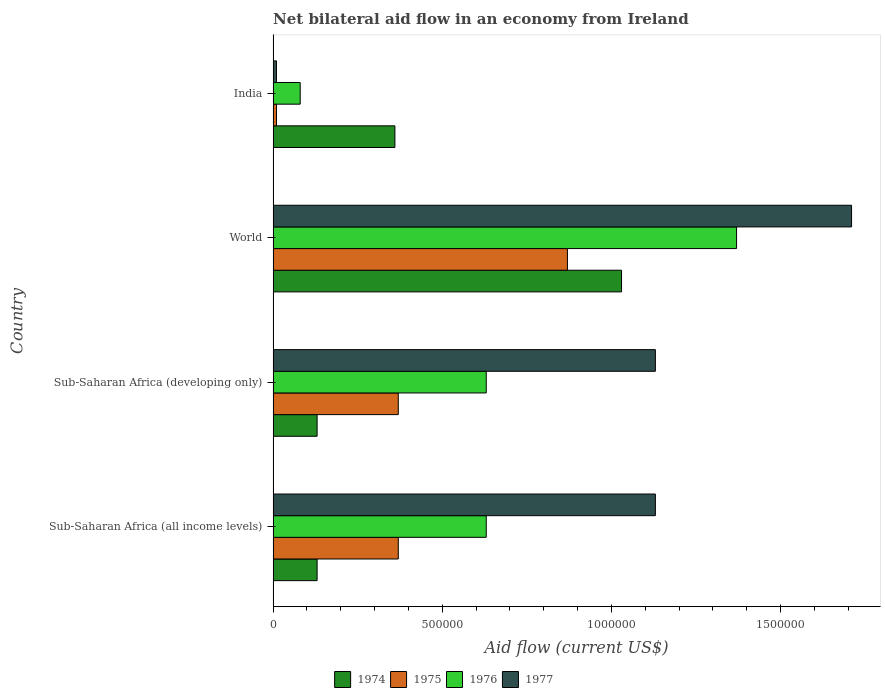How many groups of bars are there?
Give a very brief answer. 4. Are the number of bars per tick equal to the number of legend labels?
Give a very brief answer. Yes. Are the number of bars on each tick of the Y-axis equal?
Your response must be concise. Yes. How many bars are there on the 1st tick from the top?
Your answer should be compact. 4. How many bars are there on the 4th tick from the bottom?
Your response must be concise. 4. Across all countries, what is the maximum net bilateral aid flow in 1974?
Offer a terse response. 1.03e+06. In which country was the net bilateral aid flow in 1974 minimum?
Offer a terse response. Sub-Saharan Africa (all income levels). What is the total net bilateral aid flow in 1975 in the graph?
Your response must be concise. 1.62e+06. What is the difference between the net bilateral aid flow in 1977 in India and that in Sub-Saharan Africa (developing only)?
Ensure brevity in your answer.  -1.12e+06. What is the difference between the net bilateral aid flow in 1976 in India and the net bilateral aid flow in 1977 in Sub-Saharan Africa (developing only)?
Keep it short and to the point. -1.05e+06. What is the average net bilateral aid flow in 1976 per country?
Keep it short and to the point. 6.78e+05. What is the difference between the net bilateral aid flow in 1977 and net bilateral aid flow in 1974 in India?
Provide a succinct answer. -3.50e+05. What is the ratio of the net bilateral aid flow in 1974 in Sub-Saharan Africa (all income levels) to that in Sub-Saharan Africa (developing only)?
Keep it short and to the point. 1. Is the net bilateral aid flow in 1974 in Sub-Saharan Africa (developing only) less than that in World?
Offer a very short reply. Yes. What is the difference between the highest and the second highest net bilateral aid flow in 1976?
Your answer should be compact. 7.40e+05. What is the difference between the highest and the lowest net bilateral aid flow in 1975?
Your answer should be compact. 8.60e+05. In how many countries, is the net bilateral aid flow in 1977 greater than the average net bilateral aid flow in 1977 taken over all countries?
Provide a succinct answer. 3. Is the sum of the net bilateral aid flow in 1976 in Sub-Saharan Africa (developing only) and World greater than the maximum net bilateral aid flow in 1974 across all countries?
Provide a succinct answer. Yes. Is it the case that in every country, the sum of the net bilateral aid flow in 1977 and net bilateral aid flow in 1976 is greater than the sum of net bilateral aid flow in 1975 and net bilateral aid flow in 1974?
Make the answer very short. No. What does the 4th bar from the top in India represents?
Offer a very short reply. 1974. What does the 1st bar from the bottom in India represents?
Offer a terse response. 1974. Is it the case that in every country, the sum of the net bilateral aid flow in 1976 and net bilateral aid flow in 1975 is greater than the net bilateral aid flow in 1977?
Make the answer very short. No. Are all the bars in the graph horizontal?
Your answer should be compact. Yes. Are the values on the major ticks of X-axis written in scientific E-notation?
Offer a terse response. No. Does the graph contain any zero values?
Offer a very short reply. No. Does the graph contain grids?
Ensure brevity in your answer.  No. How are the legend labels stacked?
Offer a terse response. Horizontal. What is the title of the graph?
Your answer should be compact. Net bilateral aid flow in an economy from Ireland. What is the label or title of the X-axis?
Provide a succinct answer. Aid flow (current US$). What is the label or title of the Y-axis?
Give a very brief answer. Country. What is the Aid flow (current US$) of 1975 in Sub-Saharan Africa (all income levels)?
Your answer should be compact. 3.70e+05. What is the Aid flow (current US$) in 1976 in Sub-Saharan Africa (all income levels)?
Offer a very short reply. 6.30e+05. What is the Aid flow (current US$) in 1977 in Sub-Saharan Africa (all income levels)?
Provide a short and direct response. 1.13e+06. What is the Aid flow (current US$) in 1976 in Sub-Saharan Africa (developing only)?
Offer a very short reply. 6.30e+05. What is the Aid flow (current US$) of 1977 in Sub-Saharan Africa (developing only)?
Ensure brevity in your answer.  1.13e+06. What is the Aid flow (current US$) of 1974 in World?
Give a very brief answer. 1.03e+06. What is the Aid flow (current US$) of 1975 in World?
Your response must be concise. 8.70e+05. What is the Aid flow (current US$) in 1976 in World?
Your answer should be compact. 1.37e+06. What is the Aid flow (current US$) of 1977 in World?
Offer a terse response. 1.71e+06. What is the Aid flow (current US$) in 1977 in India?
Offer a terse response. 10000. Across all countries, what is the maximum Aid flow (current US$) in 1974?
Offer a terse response. 1.03e+06. Across all countries, what is the maximum Aid flow (current US$) in 1975?
Your response must be concise. 8.70e+05. Across all countries, what is the maximum Aid flow (current US$) in 1976?
Your answer should be compact. 1.37e+06. Across all countries, what is the maximum Aid flow (current US$) of 1977?
Offer a terse response. 1.71e+06. Across all countries, what is the minimum Aid flow (current US$) in 1976?
Give a very brief answer. 8.00e+04. Across all countries, what is the minimum Aid flow (current US$) in 1977?
Make the answer very short. 10000. What is the total Aid flow (current US$) in 1974 in the graph?
Provide a short and direct response. 1.65e+06. What is the total Aid flow (current US$) in 1975 in the graph?
Provide a short and direct response. 1.62e+06. What is the total Aid flow (current US$) in 1976 in the graph?
Your answer should be compact. 2.71e+06. What is the total Aid flow (current US$) in 1977 in the graph?
Give a very brief answer. 3.98e+06. What is the difference between the Aid flow (current US$) of 1974 in Sub-Saharan Africa (all income levels) and that in Sub-Saharan Africa (developing only)?
Your answer should be compact. 0. What is the difference between the Aid flow (current US$) of 1975 in Sub-Saharan Africa (all income levels) and that in Sub-Saharan Africa (developing only)?
Offer a very short reply. 0. What is the difference between the Aid flow (current US$) of 1976 in Sub-Saharan Africa (all income levels) and that in Sub-Saharan Africa (developing only)?
Make the answer very short. 0. What is the difference between the Aid flow (current US$) of 1974 in Sub-Saharan Africa (all income levels) and that in World?
Your response must be concise. -9.00e+05. What is the difference between the Aid flow (current US$) in 1975 in Sub-Saharan Africa (all income levels) and that in World?
Your response must be concise. -5.00e+05. What is the difference between the Aid flow (current US$) of 1976 in Sub-Saharan Africa (all income levels) and that in World?
Give a very brief answer. -7.40e+05. What is the difference between the Aid flow (current US$) in 1977 in Sub-Saharan Africa (all income levels) and that in World?
Ensure brevity in your answer.  -5.80e+05. What is the difference between the Aid flow (current US$) in 1975 in Sub-Saharan Africa (all income levels) and that in India?
Give a very brief answer. 3.60e+05. What is the difference between the Aid flow (current US$) in 1976 in Sub-Saharan Africa (all income levels) and that in India?
Make the answer very short. 5.50e+05. What is the difference between the Aid flow (current US$) in 1977 in Sub-Saharan Africa (all income levels) and that in India?
Your answer should be very brief. 1.12e+06. What is the difference between the Aid flow (current US$) in 1974 in Sub-Saharan Africa (developing only) and that in World?
Provide a succinct answer. -9.00e+05. What is the difference between the Aid flow (current US$) of 1975 in Sub-Saharan Africa (developing only) and that in World?
Offer a very short reply. -5.00e+05. What is the difference between the Aid flow (current US$) in 1976 in Sub-Saharan Africa (developing only) and that in World?
Make the answer very short. -7.40e+05. What is the difference between the Aid flow (current US$) in 1977 in Sub-Saharan Africa (developing only) and that in World?
Your response must be concise. -5.80e+05. What is the difference between the Aid flow (current US$) of 1976 in Sub-Saharan Africa (developing only) and that in India?
Offer a terse response. 5.50e+05. What is the difference between the Aid flow (current US$) of 1977 in Sub-Saharan Africa (developing only) and that in India?
Offer a terse response. 1.12e+06. What is the difference between the Aid flow (current US$) in 1974 in World and that in India?
Ensure brevity in your answer.  6.70e+05. What is the difference between the Aid flow (current US$) of 1975 in World and that in India?
Your response must be concise. 8.60e+05. What is the difference between the Aid flow (current US$) of 1976 in World and that in India?
Give a very brief answer. 1.29e+06. What is the difference between the Aid flow (current US$) of 1977 in World and that in India?
Offer a very short reply. 1.70e+06. What is the difference between the Aid flow (current US$) in 1974 in Sub-Saharan Africa (all income levels) and the Aid flow (current US$) in 1975 in Sub-Saharan Africa (developing only)?
Give a very brief answer. -2.40e+05. What is the difference between the Aid flow (current US$) of 1974 in Sub-Saharan Africa (all income levels) and the Aid flow (current US$) of 1976 in Sub-Saharan Africa (developing only)?
Provide a short and direct response. -5.00e+05. What is the difference between the Aid flow (current US$) of 1975 in Sub-Saharan Africa (all income levels) and the Aid flow (current US$) of 1976 in Sub-Saharan Africa (developing only)?
Your answer should be compact. -2.60e+05. What is the difference between the Aid flow (current US$) in 1975 in Sub-Saharan Africa (all income levels) and the Aid flow (current US$) in 1977 in Sub-Saharan Africa (developing only)?
Offer a very short reply. -7.60e+05. What is the difference between the Aid flow (current US$) of 1976 in Sub-Saharan Africa (all income levels) and the Aid flow (current US$) of 1977 in Sub-Saharan Africa (developing only)?
Your answer should be compact. -5.00e+05. What is the difference between the Aid flow (current US$) in 1974 in Sub-Saharan Africa (all income levels) and the Aid flow (current US$) in 1975 in World?
Your answer should be very brief. -7.40e+05. What is the difference between the Aid flow (current US$) of 1974 in Sub-Saharan Africa (all income levels) and the Aid flow (current US$) of 1976 in World?
Ensure brevity in your answer.  -1.24e+06. What is the difference between the Aid flow (current US$) in 1974 in Sub-Saharan Africa (all income levels) and the Aid flow (current US$) in 1977 in World?
Your answer should be very brief. -1.58e+06. What is the difference between the Aid flow (current US$) of 1975 in Sub-Saharan Africa (all income levels) and the Aid flow (current US$) of 1977 in World?
Offer a very short reply. -1.34e+06. What is the difference between the Aid flow (current US$) of 1976 in Sub-Saharan Africa (all income levels) and the Aid flow (current US$) of 1977 in World?
Keep it short and to the point. -1.08e+06. What is the difference between the Aid flow (current US$) of 1974 in Sub-Saharan Africa (all income levels) and the Aid flow (current US$) of 1976 in India?
Your answer should be compact. 5.00e+04. What is the difference between the Aid flow (current US$) in 1974 in Sub-Saharan Africa (all income levels) and the Aid flow (current US$) in 1977 in India?
Offer a terse response. 1.20e+05. What is the difference between the Aid flow (current US$) in 1975 in Sub-Saharan Africa (all income levels) and the Aid flow (current US$) in 1976 in India?
Your response must be concise. 2.90e+05. What is the difference between the Aid flow (current US$) of 1976 in Sub-Saharan Africa (all income levels) and the Aid flow (current US$) of 1977 in India?
Make the answer very short. 6.20e+05. What is the difference between the Aid flow (current US$) of 1974 in Sub-Saharan Africa (developing only) and the Aid flow (current US$) of 1975 in World?
Provide a succinct answer. -7.40e+05. What is the difference between the Aid flow (current US$) of 1974 in Sub-Saharan Africa (developing only) and the Aid flow (current US$) of 1976 in World?
Your answer should be very brief. -1.24e+06. What is the difference between the Aid flow (current US$) in 1974 in Sub-Saharan Africa (developing only) and the Aid flow (current US$) in 1977 in World?
Keep it short and to the point. -1.58e+06. What is the difference between the Aid flow (current US$) in 1975 in Sub-Saharan Africa (developing only) and the Aid flow (current US$) in 1977 in World?
Provide a short and direct response. -1.34e+06. What is the difference between the Aid flow (current US$) in 1976 in Sub-Saharan Africa (developing only) and the Aid flow (current US$) in 1977 in World?
Provide a short and direct response. -1.08e+06. What is the difference between the Aid flow (current US$) in 1974 in Sub-Saharan Africa (developing only) and the Aid flow (current US$) in 1975 in India?
Offer a very short reply. 1.20e+05. What is the difference between the Aid flow (current US$) in 1974 in Sub-Saharan Africa (developing only) and the Aid flow (current US$) in 1976 in India?
Give a very brief answer. 5.00e+04. What is the difference between the Aid flow (current US$) of 1974 in Sub-Saharan Africa (developing only) and the Aid flow (current US$) of 1977 in India?
Ensure brevity in your answer.  1.20e+05. What is the difference between the Aid flow (current US$) of 1975 in Sub-Saharan Africa (developing only) and the Aid flow (current US$) of 1976 in India?
Your response must be concise. 2.90e+05. What is the difference between the Aid flow (current US$) of 1976 in Sub-Saharan Africa (developing only) and the Aid flow (current US$) of 1977 in India?
Ensure brevity in your answer.  6.20e+05. What is the difference between the Aid flow (current US$) in 1974 in World and the Aid flow (current US$) in 1975 in India?
Provide a short and direct response. 1.02e+06. What is the difference between the Aid flow (current US$) in 1974 in World and the Aid flow (current US$) in 1976 in India?
Offer a terse response. 9.50e+05. What is the difference between the Aid flow (current US$) of 1974 in World and the Aid flow (current US$) of 1977 in India?
Keep it short and to the point. 1.02e+06. What is the difference between the Aid flow (current US$) of 1975 in World and the Aid flow (current US$) of 1976 in India?
Your response must be concise. 7.90e+05. What is the difference between the Aid flow (current US$) of 1975 in World and the Aid flow (current US$) of 1977 in India?
Make the answer very short. 8.60e+05. What is the difference between the Aid flow (current US$) in 1976 in World and the Aid flow (current US$) in 1977 in India?
Give a very brief answer. 1.36e+06. What is the average Aid flow (current US$) of 1974 per country?
Your answer should be compact. 4.12e+05. What is the average Aid flow (current US$) of 1975 per country?
Your answer should be compact. 4.05e+05. What is the average Aid flow (current US$) of 1976 per country?
Provide a short and direct response. 6.78e+05. What is the average Aid flow (current US$) of 1977 per country?
Ensure brevity in your answer.  9.95e+05. What is the difference between the Aid flow (current US$) of 1974 and Aid flow (current US$) of 1975 in Sub-Saharan Africa (all income levels)?
Provide a succinct answer. -2.40e+05. What is the difference between the Aid flow (current US$) of 1974 and Aid flow (current US$) of 1976 in Sub-Saharan Africa (all income levels)?
Offer a terse response. -5.00e+05. What is the difference between the Aid flow (current US$) in 1974 and Aid flow (current US$) in 1977 in Sub-Saharan Africa (all income levels)?
Offer a terse response. -1.00e+06. What is the difference between the Aid flow (current US$) of 1975 and Aid flow (current US$) of 1976 in Sub-Saharan Africa (all income levels)?
Your response must be concise. -2.60e+05. What is the difference between the Aid flow (current US$) in 1975 and Aid flow (current US$) in 1977 in Sub-Saharan Africa (all income levels)?
Give a very brief answer. -7.60e+05. What is the difference between the Aid flow (current US$) of 1976 and Aid flow (current US$) of 1977 in Sub-Saharan Africa (all income levels)?
Your answer should be very brief. -5.00e+05. What is the difference between the Aid flow (current US$) of 1974 and Aid flow (current US$) of 1976 in Sub-Saharan Africa (developing only)?
Provide a succinct answer. -5.00e+05. What is the difference between the Aid flow (current US$) in 1974 and Aid flow (current US$) in 1977 in Sub-Saharan Africa (developing only)?
Offer a terse response. -1.00e+06. What is the difference between the Aid flow (current US$) of 1975 and Aid flow (current US$) of 1976 in Sub-Saharan Africa (developing only)?
Your response must be concise. -2.60e+05. What is the difference between the Aid flow (current US$) of 1975 and Aid flow (current US$) of 1977 in Sub-Saharan Africa (developing only)?
Your answer should be very brief. -7.60e+05. What is the difference between the Aid flow (current US$) of 1976 and Aid flow (current US$) of 1977 in Sub-Saharan Africa (developing only)?
Give a very brief answer. -5.00e+05. What is the difference between the Aid flow (current US$) in 1974 and Aid flow (current US$) in 1976 in World?
Provide a succinct answer. -3.40e+05. What is the difference between the Aid flow (current US$) in 1974 and Aid flow (current US$) in 1977 in World?
Give a very brief answer. -6.80e+05. What is the difference between the Aid flow (current US$) in 1975 and Aid flow (current US$) in 1976 in World?
Your response must be concise. -5.00e+05. What is the difference between the Aid flow (current US$) of 1975 and Aid flow (current US$) of 1977 in World?
Provide a short and direct response. -8.40e+05. What is the difference between the Aid flow (current US$) in 1974 and Aid flow (current US$) in 1975 in India?
Your response must be concise. 3.50e+05. What is the difference between the Aid flow (current US$) of 1974 and Aid flow (current US$) of 1976 in India?
Offer a terse response. 2.80e+05. What is the difference between the Aid flow (current US$) in 1974 and Aid flow (current US$) in 1977 in India?
Your answer should be very brief. 3.50e+05. What is the difference between the Aid flow (current US$) in 1975 and Aid flow (current US$) in 1976 in India?
Make the answer very short. -7.00e+04. What is the difference between the Aid flow (current US$) in 1976 and Aid flow (current US$) in 1977 in India?
Your response must be concise. 7.00e+04. What is the ratio of the Aid flow (current US$) of 1974 in Sub-Saharan Africa (all income levels) to that in Sub-Saharan Africa (developing only)?
Your answer should be very brief. 1. What is the ratio of the Aid flow (current US$) of 1975 in Sub-Saharan Africa (all income levels) to that in Sub-Saharan Africa (developing only)?
Offer a terse response. 1. What is the ratio of the Aid flow (current US$) in 1974 in Sub-Saharan Africa (all income levels) to that in World?
Your response must be concise. 0.13. What is the ratio of the Aid flow (current US$) in 1975 in Sub-Saharan Africa (all income levels) to that in World?
Make the answer very short. 0.43. What is the ratio of the Aid flow (current US$) in 1976 in Sub-Saharan Africa (all income levels) to that in World?
Give a very brief answer. 0.46. What is the ratio of the Aid flow (current US$) of 1977 in Sub-Saharan Africa (all income levels) to that in World?
Keep it short and to the point. 0.66. What is the ratio of the Aid flow (current US$) of 1974 in Sub-Saharan Africa (all income levels) to that in India?
Provide a succinct answer. 0.36. What is the ratio of the Aid flow (current US$) in 1976 in Sub-Saharan Africa (all income levels) to that in India?
Provide a succinct answer. 7.88. What is the ratio of the Aid flow (current US$) of 1977 in Sub-Saharan Africa (all income levels) to that in India?
Keep it short and to the point. 113. What is the ratio of the Aid flow (current US$) in 1974 in Sub-Saharan Africa (developing only) to that in World?
Make the answer very short. 0.13. What is the ratio of the Aid flow (current US$) in 1975 in Sub-Saharan Africa (developing only) to that in World?
Give a very brief answer. 0.43. What is the ratio of the Aid flow (current US$) in 1976 in Sub-Saharan Africa (developing only) to that in World?
Your response must be concise. 0.46. What is the ratio of the Aid flow (current US$) in 1977 in Sub-Saharan Africa (developing only) to that in World?
Ensure brevity in your answer.  0.66. What is the ratio of the Aid flow (current US$) in 1974 in Sub-Saharan Africa (developing only) to that in India?
Keep it short and to the point. 0.36. What is the ratio of the Aid flow (current US$) in 1976 in Sub-Saharan Africa (developing only) to that in India?
Your response must be concise. 7.88. What is the ratio of the Aid flow (current US$) of 1977 in Sub-Saharan Africa (developing only) to that in India?
Your answer should be very brief. 113. What is the ratio of the Aid flow (current US$) in 1974 in World to that in India?
Provide a short and direct response. 2.86. What is the ratio of the Aid flow (current US$) of 1975 in World to that in India?
Provide a short and direct response. 87. What is the ratio of the Aid flow (current US$) in 1976 in World to that in India?
Your response must be concise. 17.12. What is the ratio of the Aid flow (current US$) in 1977 in World to that in India?
Keep it short and to the point. 171. What is the difference between the highest and the second highest Aid flow (current US$) of 1974?
Your answer should be compact. 6.70e+05. What is the difference between the highest and the second highest Aid flow (current US$) of 1976?
Offer a terse response. 7.40e+05. What is the difference between the highest and the second highest Aid flow (current US$) in 1977?
Offer a terse response. 5.80e+05. What is the difference between the highest and the lowest Aid flow (current US$) of 1975?
Give a very brief answer. 8.60e+05. What is the difference between the highest and the lowest Aid flow (current US$) in 1976?
Provide a succinct answer. 1.29e+06. What is the difference between the highest and the lowest Aid flow (current US$) in 1977?
Offer a terse response. 1.70e+06. 